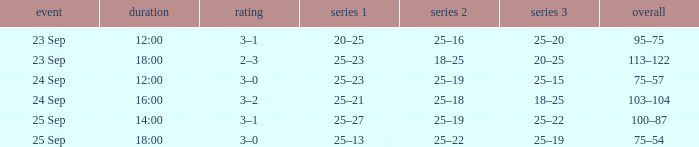What was the score when the time was 14:00? 3–1. 